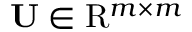Convert formula to latex. <formula><loc_0><loc_0><loc_500><loc_500>U \in R ^ { m \times m }</formula> 